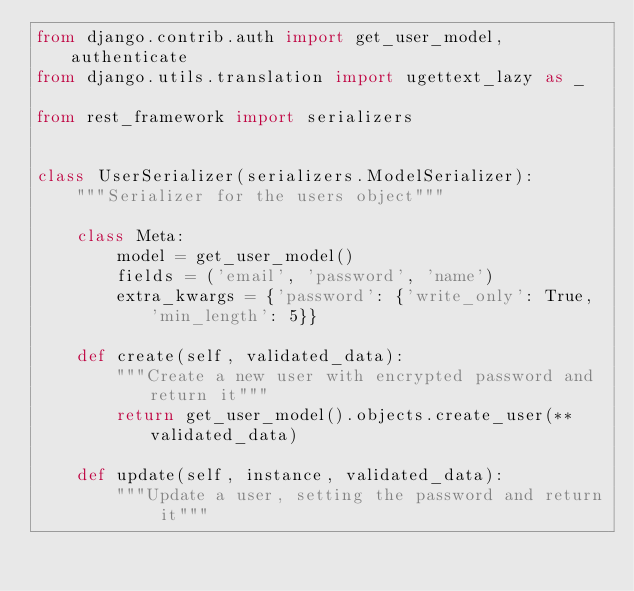<code> <loc_0><loc_0><loc_500><loc_500><_Python_>from django.contrib.auth import get_user_model, authenticate
from django.utils.translation import ugettext_lazy as _

from rest_framework import serializers


class UserSerializer(serializers.ModelSerializer):
    """Serializer for the users object"""

    class Meta:
        model = get_user_model()
        fields = ('email', 'password', 'name')
        extra_kwargs = {'password': {'write_only': True, 'min_length': 5}}

    def create(self, validated_data):
        """Create a new user with encrypted password and return it"""
        return get_user_model().objects.create_user(**validated_data)

    def update(self, instance, validated_data):
        """Update a user, setting the password and return it"""</code> 